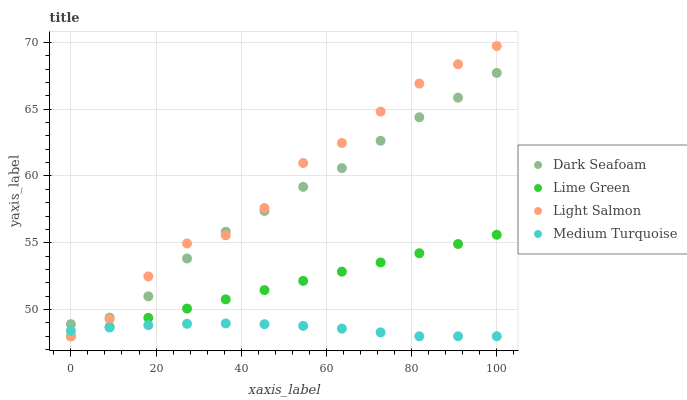Does Medium Turquoise have the minimum area under the curve?
Answer yes or no. Yes. Does Light Salmon have the maximum area under the curve?
Answer yes or no. Yes. Does Lime Green have the minimum area under the curve?
Answer yes or no. No. Does Lime Green have the maximum area under the curve?
Answer yes or no. No. Is Lime Green the smoothest?
Answer yes or no. Yes. Is Light Salmon the roughest?
Answer yes or no. Yes. Is Light Salmon the smoothest?
Answer yes or no. No. Is Lime Green the roughest?
Answer yes or no. No. Does Lime Green have the lowest value?
Answer yes or no. Yes. Does Light Salmon have the highest value?
Answer yes or no. Yes. Does Lime Green have the highest value?
Answer yes or no. No. Is Medium Turquoise less than Dark Seafoam?
Answer yes or no. Yes. Is Dark Seafoam greater than Medium Turquoise?
Answer yes or no. Yes. Does Medium Turquoise intersect Light Salmon?
Answer yes or no. Yes. Is Medium Turquoise less than Light Salmon?
Answer yes or no. No. Is Medium Turquoise greater than Light Salmon?
Answer yes or no. No. Does Medium Turquoise intersect Dark Seafoam?
Answer yes or no. No. 